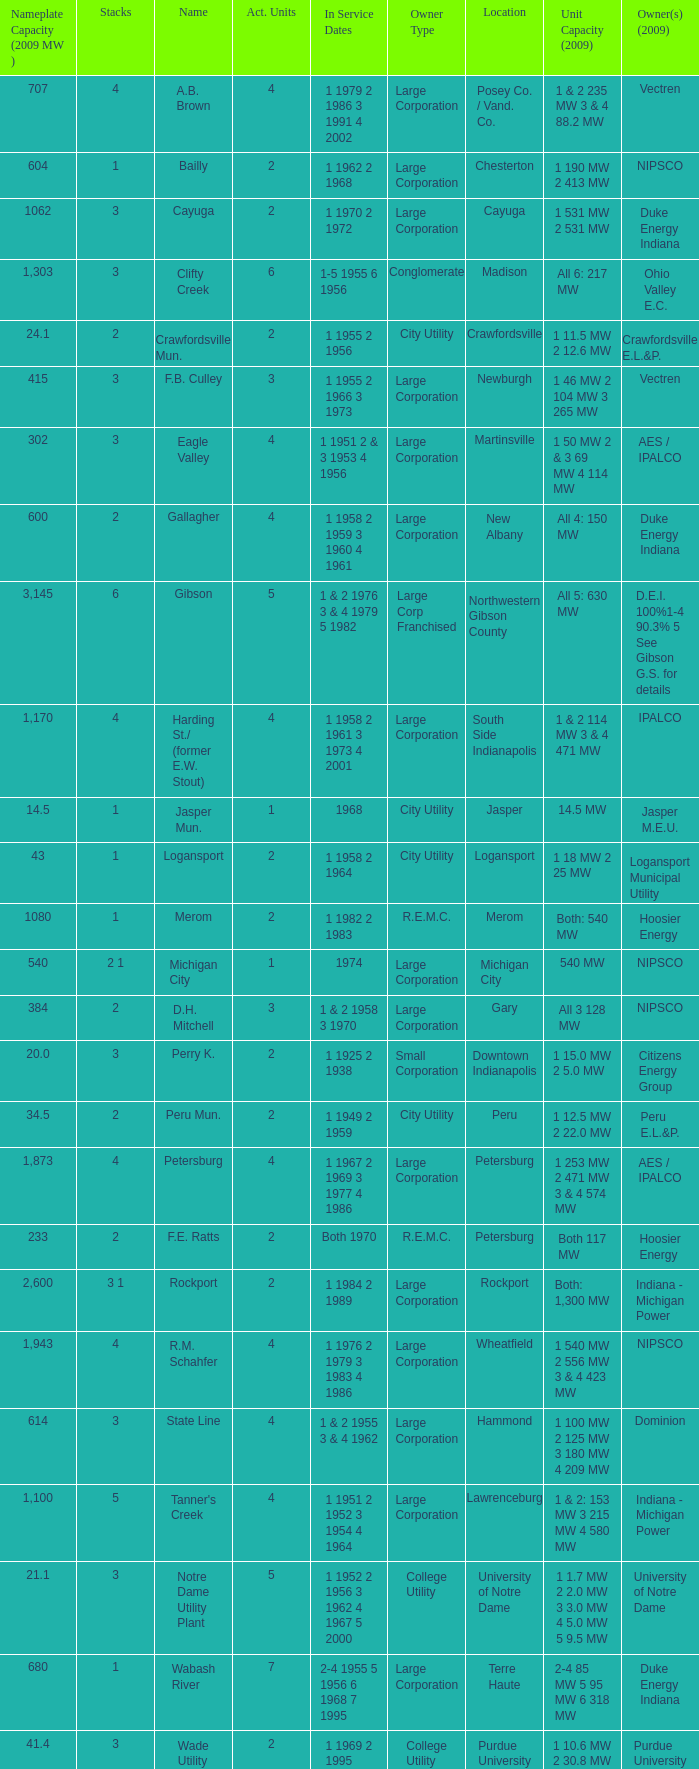Specify the heaps for 1 1969 2 1995 3.0. 